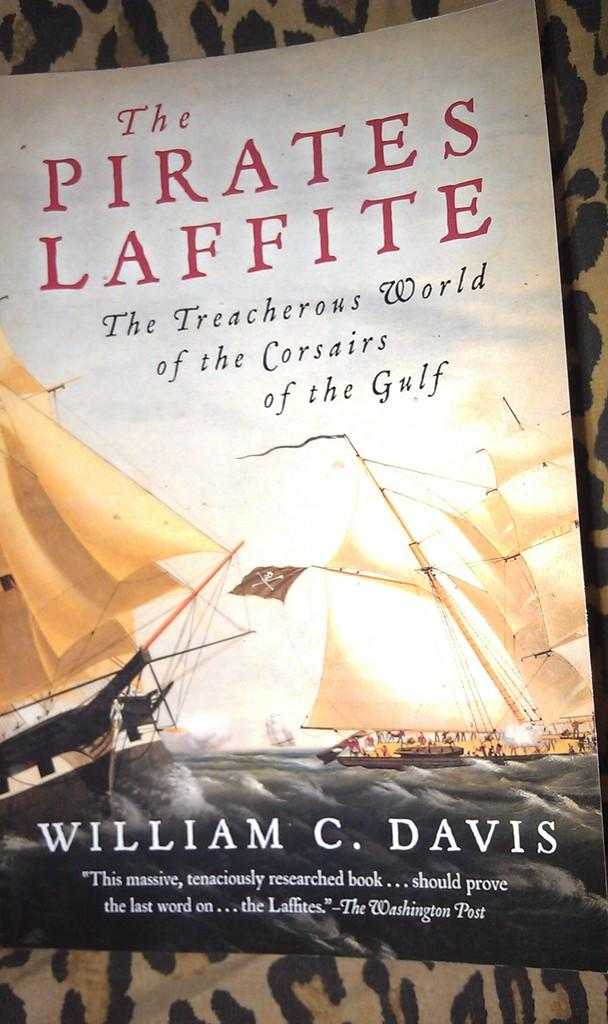<image>
Summarize the visual content of the image. A book titled The Pirates Laffite by William Davis sits on top of a leopard print blanket 